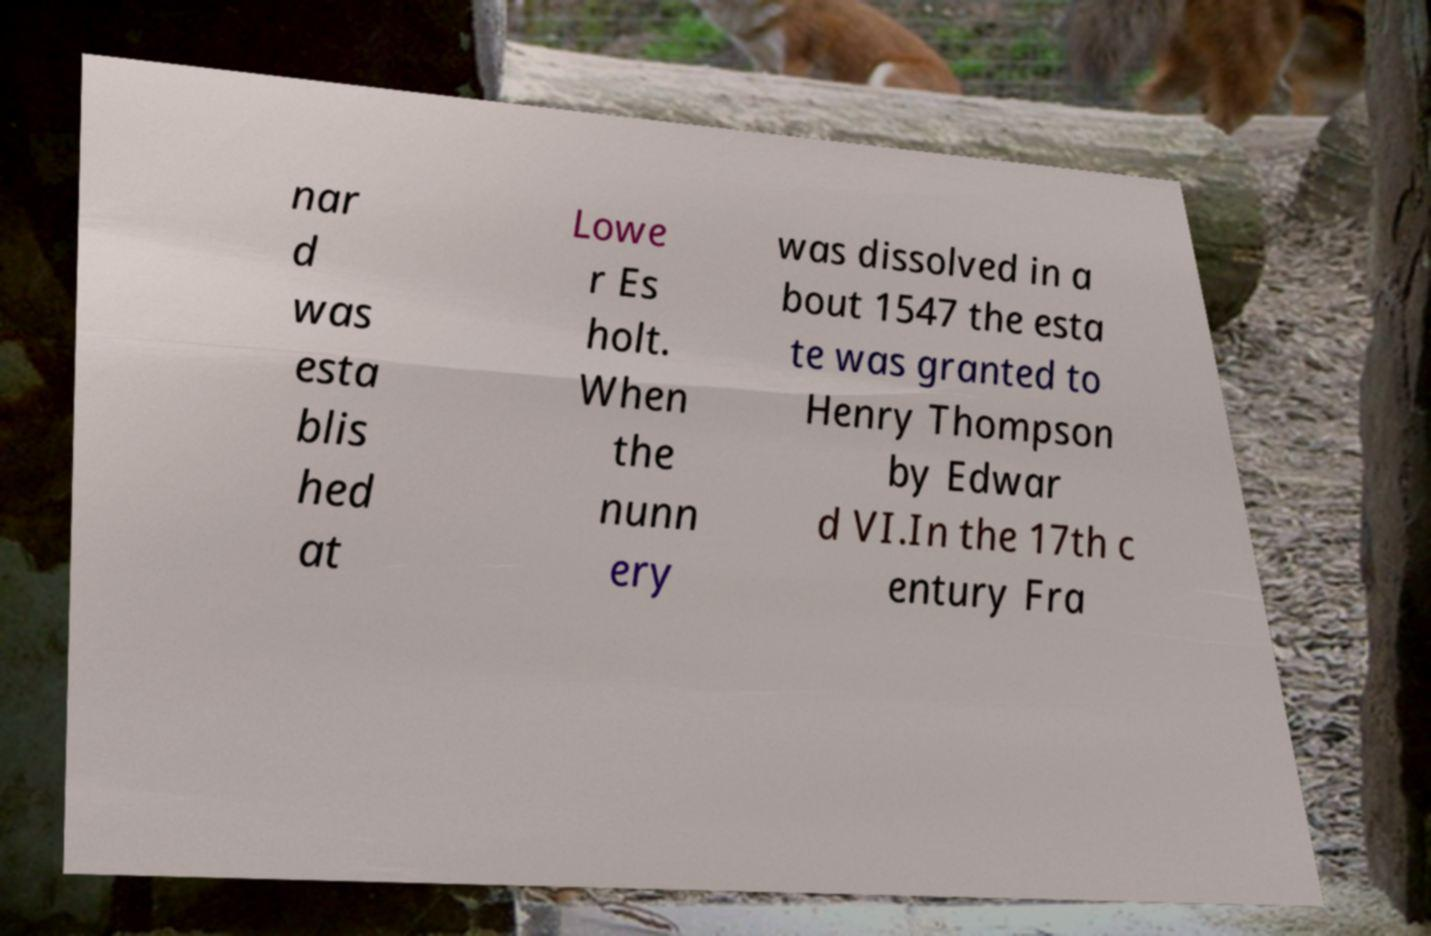Please identify and transcribe the text found in this image. nar d was esta blis hed at Lowe r Es holt. When the nunn ery was dissolved in a bout 1547 the esta te was granted to Henry Thompson by Edwar d VI.In the 17th c entury Fra 